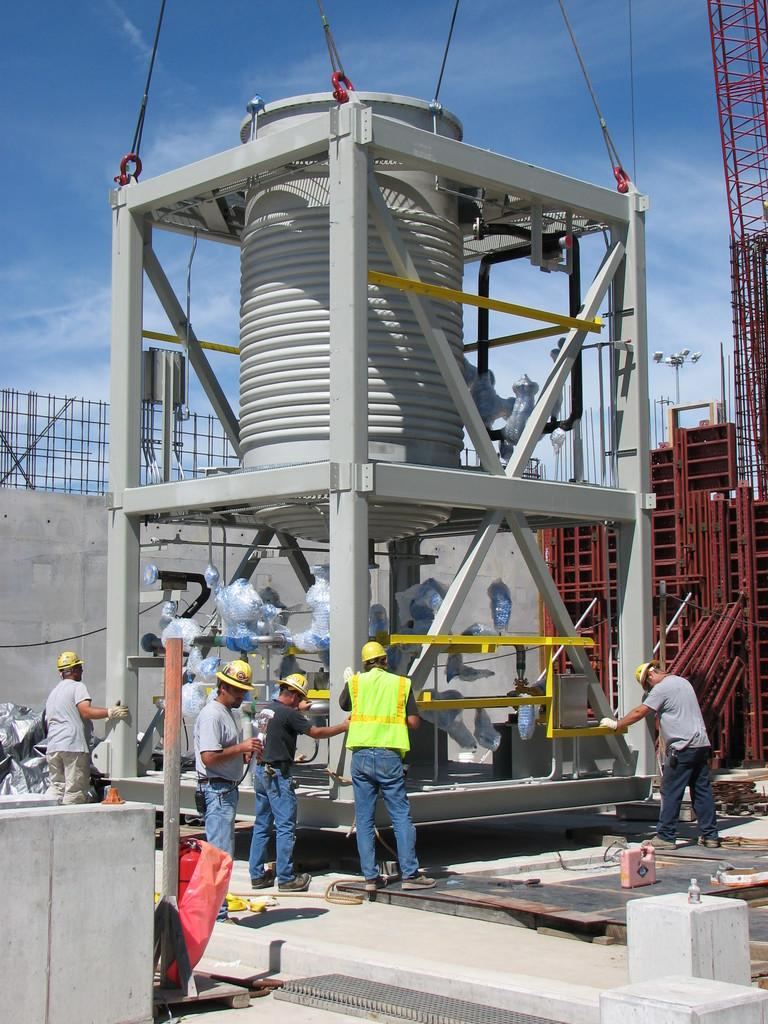What is happening in the image? There are persons standing in front of an object. Can you describe the object in the image? Unfortunately, the facts provided do not give enough information to describe the object. What can be seen in the right corner of the image? There are red rows in the right corner of the image. What is the opinion of the wax exchange in the image? There is no wax or exchange present in the image, so it is not possible to determine an opinion about it. 